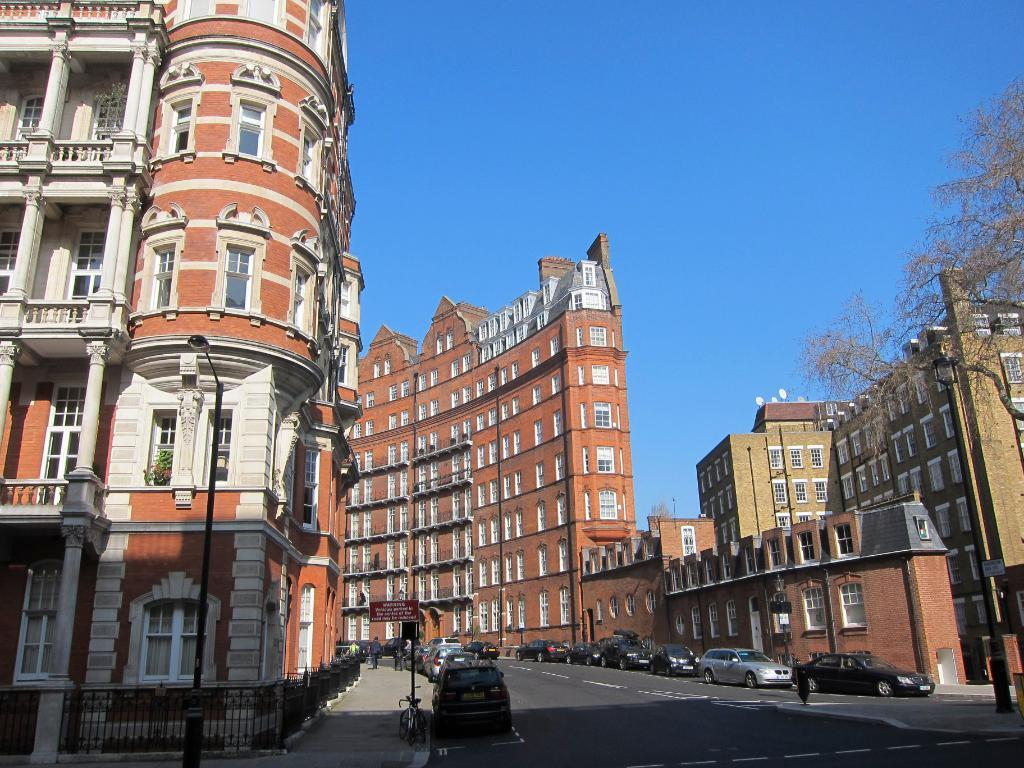What is located on the left side of the image? There are vehicles on the left side of the image. What is located on the right side of the image? There are vehicles on the right side of the image. Where are the vehicles situated in the image? The vehicles are on the road. What else can be seen in the image besides the vehicles? There are buildings visible in the image. What is visible at the top of the image? The sky is visible at the top of the image. What type of straw is being used to play with the toy in the image? There is no straw or toy present in the image; it features vehicles on the road and buildings in the background. 